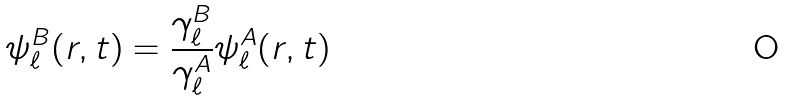Convert formula to latex. <formula><loc_0><loc_0><loc_500><loc_500>\psi _ { \ell } ^ { B } ( r , t ) = \frac { \gamma _ { \ell } ^ { B } } { \gamma _ { \ell } ^ { A } } \psi _ { \ell } ^ { A } ( r , t )</formula> 